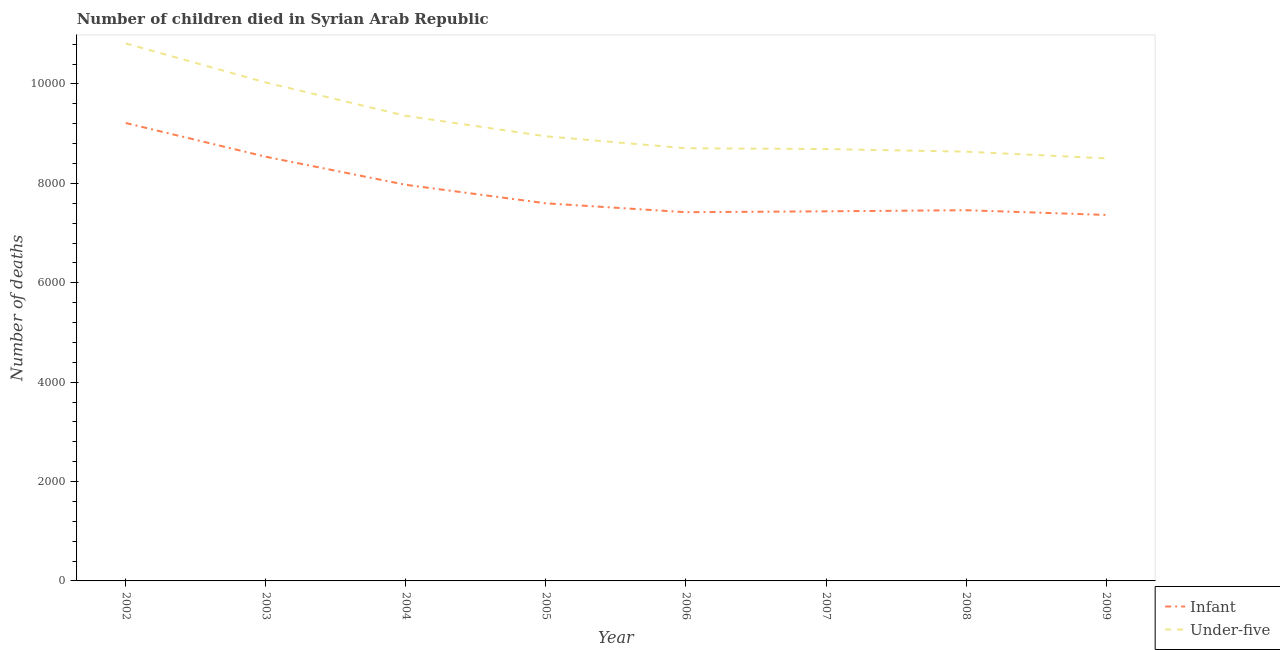What is the number of infant deaths in 2005?
Ensure brevity in your answer.  7599. Across all years, what is the maximum number of infant deaths?
Your answer should be very brief. 9215. Across all years, what is the minimum number of under-five deaths?
Your response must be concise. 8504. In which year was the number of under-five deaths maximum?
Offer a very short reply. 2002. What is the total number of under-five deaths in the graph?
Make the answer very short. 7.37e+04. What is the difference between the number of infant deaths in 2002 and that in 2006?
Ensure brevity in your answer.  1795. What is the difference between the number of infant deaths in 2004 and the number of under-five deaths in 2008?
Offer a very short reply. -667. What is the average number of under-five deaths per year?
Provide a short and direct response. 9211.5. In the year 2009, what is the difference between the number of under-five deaths and number of infant deaths?
Your answer should be very brief. 1139. What is the ratio of the number of under-five deaths in 2004 to that in 2009?
Provide a short and direct response. 1.1. What is the difference between the highest and the second highest number of infant deaths?
Provide a succinct answer. 679. What is the difference between the highest and the lowest number of under-five deaths?
Give a very brief answer. 2312. In how many years, is the number of infant deaths greater than the average number of infant deaths taken over all years?
Your answer should be very brief. 3. How many lines are there?
Your response must be concise. 2. What is the difference between two consecutive major ticks on the Y-axis?
Your answer should be compact. 2000. Are the values on the major ticks of Y-axis written in scientific E-notation?
Ensure brevity in your answer.  No. Where does the legend appear in the graph?
Offer a terse response. Bottom right. How many legend labels are there?
Make the answer very short. 2. What is the title of the graph?
Your answer should be compact. Number of children died in Syrian Arab Republic. Does "Malaria" appear as one of the legend labels in the graph?
Your response must be concise. No. What is the label or title of the Y-axis?
Give a very brief answer. Number of deaths. What is the Number of deaths in Infant in 2002?
Provide a short and direct response. 9215. What is the Number of deaths of Under-five in 2002?
Make the answer very short. 1.08e+04. What is the Number of deaths of Infant in 2003?
Provide a succinct answer. 8536. What is the Number of deaths of Under-five in 2003?
Provide a short and direct response. 1.00e+04. What is the Number of deaths of Infant in 2004?
Provide a succinct answer. 7971. What is the Number of deaths in Under-five in 2004?
Your response must be concise. 9359. What is the Number of deaths in Infant in 2005?
Provide a short and direct response. 7599. What is the Number of deaths of Under-five in 2005?
Offer a terse response. 8947. What is the Number of deaths in Infant in 2006?
Make the answer very short. 7420. What is the Number of deaths in Under-five in 2006?
Make the answer very short. 8707. What is the Number of deaths in Infant in 2007?
Your answer should be very brief. 7438. What is the Number of deaths in Under-five in 2007?
Your answer should be compact. 8691. What is the Number of deaths of Infant in 2008?
Offer a terse response. 7460. What is the Number of deaths in Under-five in 2008?
Your response must be concise. 8638. What is the Number of deaths in Infant in 2009?
Keep it short and to the point. 7365. What is the Number of deaths of Under-five in 2009?
Offer a very short reply. 8504. Across all years, what is the maximum Number of deaths in Infant?
Your answer should be compact. 9215. Across all years, what is the maximum Number of deaths of Under-five?
Ensure brevity in your answer.  1.08e+04. Across all years, what is the minimum Number of deaths in Infant?
Your answer should be very brief. 7365. Across all years, what is the minimum Number of deaths of Under-five?
Offer a very short reply. 8504. What is the total Number of deaths in Infant in the graph?
Give a very brief answer. 6.30e+04. What is the total Number of deaths in Under-five in the graph?
Provide a succinct answer. 7.37e+04. What is the difference between the Number of deaths of Infant in 2002 and that in 2003?
Your answer should be very brief. 679. What is the difference between the Number of deaths in Under-five in 2002 and that in 2003?
Your response must be concise. 786. What is the difference between the Number of deaths of Infant in 2002 and that in 2004?
Offer a very short reply. 1244. What is the difference between the Number of deaths in Under-five in 2002 and that in 2004?
Offer a terse response. 1457. What is the difference between the Number of deaths of Infant in 2002 and that in 2005?
Provide a succinct answer. 1616. What is the difference between the Number of deaths of Under-five in 2002 and that in 2005?
Give a very brief answer. 1869. What is the difference between the Number of deaths of Infant in 2002 and that in 2006?
Provide a short and direct response. 1795. What is the difference between the Number of deaths in Under-five in 2002 and that in 2006?
Offer a very short reply. 2109. What is the difference between the Number of deaths of Infant in 2002 and that in 2007?
Give a very brief answer. 1777. What is the difference between the Number of deaths of Under-five in 2002 and that in 2007?
Offer a very short reply. 2125. What is the difference between the Number of deaths of Infant in 2002 and that in 2008?
Your response must be concise. 1755. What is the difference between the Number of deaths of Under-five in 2002 and that in 2008?
Offer a terse response. 2178. What is the difference between the Number of deaths in Infant in 2002 and that in 2009?
Your answer should be compact. 1850. What is the difference between the Number of deaths in Under-five in 2002 and that in 2009?
Ensure brevity in your answer.  2312. What is the difference between the Number of deaths in Infant in 2003 and that in 2004?
Provide a short and direct response. 565. What is the difference between the Number of deaths in Under-five in 2003 and that in 2004?
Offer a terse response. 671. What is the difference between the Number of deaths of Infant in 2003 and that in 2005?
Your answer should be compact. 937. What is the difference between the Number of deaths of Under-five in 2003 and that in 2005?
Your answer should be very brief. 1083. What is the difference between the Number of deaths of Infant in 2003 and that in 2006?
Provide a short and direct response. 1116. What is the difference between the Number of deaths in Under-five in 2003 and that in 2006?
Keep it short and to the point. 1323. What is the difference between the Number of deaths in Infant in 2003 and that in 2007?
Give a very brief answer. 1098. What is the difference between the Number of deaths in Under-five in 2003 and that in 2007?
Provide a short and direct response. 1339. What is the difference between the Number of deaths in Infant in 2003 and that in 2008?
Your response must be concise. 1076. What is the difference between the Number of deaths in Under-five in 2003 and that in 2008?
Make the answer very short. 1392. What is the difference between the Number of deaths of Infant in 2003 and that in 2009?
Your answer should be compact. 1171. What is the difference between the Number of deaths of Under-five in 2003 and that in 2009?
Ensure brevity in your answer.  1526. What is the difference between the Number of deaths of Infant in 2004 and that in 2005?
Give a very brief answer. 372. What is the difference between the Number of deaths of Under-five in 2004 and that in 2005?
Your answer should be very brief. 412. What is the difference between the Number of deaths in Infant in 2004 and that in 2006?
Your answer should be very brief. 551. What is the difference between the Number of deaths of Under-five in 2004 and that in 2006?
Your response must be concise. 652. What is the difference between the Number of deaths of Infant in 2004 and that in 2007?
Ensure brevity in your answer.  533. What is the difference between the Number of deaths in Under-five in 2004 and that in 2007?
Provide a short and direct response. 668. What is the difference between the Number of deaths in Infant in 2004 and that in 2008?
Give a very brief answer. 511. What is the difference between the Number of deaths of Under-five in 2004 and that in 2008?
Give a very brief answer. 721. What is the difference between the Number of deaths of Infant in 2004 and that in 2009?
Provide a succinct answer. 606. What is the difference between the Number of deaths in Under-five in 2004 and that in 2009?
Provide a succinct answer. 855. What is the difference between the Number of deaths in Infant in 2005 and that in 2006?
Ensure brevity in your answer.  179. What is the difference between the Number of deaths of Under-five in 2005 and that in 2006?
Your answer should be compact. 240. What is the difference between the Number of deaths of Infant in 2005 and that in 2007?
Your answer should be compact. 161. What is the difference between the Number of deaths in Under-five in 2005 and that in 2007?
Your answer should be very brief. 256. What is the difference between the Number of deaths of Infant in 2005 and that in 2008?
Your answer should be compact. 139. What is the difference between the Number of deaths in Under-five in 2005 and that in 2008?
Keep it short and to the point. 309. What is the difference between the Number of deaths in Infant in 2005 and that in 2009?
Offer a terse response. 234. What is the difference between the Number of deaths in Under-five in 2005 and that in 2009?
Provide a succinct answer. 443. What is the difference between the Number of deaths in Infant in 2006 and that in 2007?
Keep it short and to the point. -18. What is the difference between the Number of deaths of Under-five in 2006 and that in 2009?
Provide a succinct answer. 203. What is the difference between the Number of deaths in Infant in 2007 and that in 2008?
Make the answer very short. -22. What is the difference between the Number of deaths in Under-five in 2007 and that in 2009?
Make the answer very short. 187. What is the difference between the Number of deaths of Infant in 2008 and that in 2009?
Ensure brevity in your answer.  95. What is the difference between the Number of deaths of Under-five in 2008 and that in 2009?
Provide a succinct answer. 134. What is the difference between the Number of deaths in Infant in 2002 and the Number of deaths in Under-five in 2003?
Make the answer very short. -815. What is the difference between the Number of deaths in Infant in 2002 and the Number of deaths in Under-five in 2004?
Ensure brevity in your answer.  -144. What is the difference between the Number of deaths of Infant in 2002 and the Number of deaths of Under-five in 2005?
Keep it short and to the point. 268. What is the difference between the Number of deaths in Infant in 2002 and the Number of deaths in Under-five in 2006?
Your response must be concise. 508. What is the difference between the Number of deaths of Infant in 2002 and the Number of deaths of Under-five in 2007?
Your response must be concise. 524. What is the difference between the Number of deaths in Infant in 2002 and the Number of deaths in Under-five in 2008?
Provide a short and direct response. 577. What is the difference between the Number of deaths of Infant in 2002 and the Number of deaths of Under-five in 2009?
Provide a short and direct response. 711. What is the difference between the Number of deaths in Infant in 2003 and the Number of deaths in Under-five in 2004?
Make the answer very short. -823. What is the difference between the Number of deaths in Infant in 2003 and the Number of deaths in Under-five in 2005?
Offer a very short reply. -411. What is the difference between the Number of deaths of Infant in 2003 and the Number of deaths of Under-five in 2006?
Your response must be concise. -171. What is the difference between the Number of deaths in Infant in 2003 and the Number of deaths in Under-five in 2007?
Keep it short and to the point. -155. What is the difference between the Number of deaths in Infant in 2003 and the Number of deaths in Under-five in 2008?
Offer a terse response. -102. What is the difference between the Number of deaths in Infant in 2003 and the Number of deaths in Under-five in 2009?
Ensure brevity in your answer.  32. What is the difference between the Number of deaths of Infant in 2004 and the Number of deaths of Under-five in 2005?
Offer a terse response. -976. What is the difference between the Number of deaths in Infant in 2004 and the Number of deaths in Under-five in 2006?
Make the answer very short. -736. What is the difference between the Number of deaths in Infant in 2004 and the Number of deaths in Under-five in 2007?
Provide a succinct answer. -720. What is the difference between the Number of deaths in Infant in 2004 and the Number of deaths in Under-five in 2008?
Make the answer very short. -667. What is the difference between the Number of deaths in Infant in 2004 and the Number of deaths in Under-five in 2009?
Your response must be concise. -533. What is the difference between the Number of deaths of Infant in 2005 and the Number of deaths of Under-five in 2006?
Your answer should be compact. -1108. What is the difference between the Number of deaths in Infant in 2005 and the Number of deaths in Under-five in 2007?
Your answer should be very brief. -1092. What is the difference between the Number of deaths in Infant in 2005 and the Number of deaths in Under-five in 2008?
Your answer should be very brief. -1039. What is the difference between the Number of deaths in Infant in 2005 and the Number of deaths in Under-five in 2009?
Your response must be concise. -905. What is the difference between the Number of deaths of Infant in 2006 and the Number of deaths of Under-five in 2007?
Give a very brief answer. -1271. What is the difference between the Number of deaths of Infant in 2006 and the Number of deaths of Under-five in 2008?
Give a very brief answer. -1218. What is the difference between the Number of deaths of Infant in 2006 and the Number of deaths of Under-five in 2009?
Your answer should be compact. -1084. What is the difference between the Number of deaths of Infant in 2007 and the Number of deaths of Under-five in 2008?
Your response must be concise. -1200. What is the difference between the Number of deaths in Infant in 2007 and the Number of deaths in Under-five in 2009?
Offer a very short reply. -1066. What is the difference between the Number of deaths of Infant in 2008 and the Number of deaths of Under-five in 2009?
Make the answer very short. -1044. What is the average Number of deaths of Infant per year?
Give a very brief answer. 7875.5. What is the average Number of deaths in Under-five per year?
Your answer should be very brief. 9211.5. In the year 2002, what is the difference between the Number of deaths of Infant and Number of deaths of Under-five?
Ensure brevity in your answer.  -1601. In the year 2003, what is the difference between the Number of deaths of Infant and Number of deaths of Under-five?
Keep it short and to the point. -1494. In the year 2004, what is the difference between the Number of deaths in Infant and Number of deaths in Under-five?
Ensure brevity in your answer.  -1388. In the year 2005, what is the difference between the Number of deaths in Infant and Number of deaths in Under-five?
Provide a succinct answer. -1348. In the year 2006, what is the difference between the Number of deaths of Infant and Number of deaths of Under-five?
Provide a short and direct response. -1287. In the year 2007, what is the difference between the Number of deaths of Infant and Number of deaths of Under-five?
Give a very brief answer. -1253. In the year 2008, what is the difference between the Number of deaths in Infant and Number of deaths in Under-five?
Offer a terse response. -1178. In the year 2009, what is the difference between the Number of deaths of Infant and Number of deaths of Under-five?
Give a very brief answer. -1139. What is the ratio of the Number of deaths in Infant in 2002 to that in 2003?
Your answer should be compact. 1.08. What is the ratio of the Number of deaths of Under-five in 2002 to that in 2003?
Your answer should be compact. 1.08. What is the ratio of the Number of deaths in Infant in 2002 to that in 2004?
Provide a succinct answer. 1.16. What is the ratio of the Number of deaths in Under-five in 2002 to that in 2004?
Provide a short and direct response. 1.16. What is the ratio of the Number of deaths in Infant in 2002 to that in 2005?
Offer a terse response. 1.21. What is the ratio of the Number of deaths of Under-five in 2002 to that in 2005?
Your answer should be very brief. 1.21. What is the ratio of the Number of deaths of Infant in 2002 to that in 2006?
Your answer should be very brief. 1.24. What is the ratio of the Number of deaths of Under-five in 2002 to that in 2006?
Your response must be concise. 1.24. What is the ratio of the Number of deaths of Infant in 2002 to that in 2007?
Your response must be concise. 1.24. What is the ratio of the Number of deaths in Under-five in 2002 to that in 2007?
Your response must be concise. 1.24. What is the ratio of the Number of deaths in Infant in 2002 to that in 2008?
Provide a short and direct response. 1.24. What is the ratio of the Number of deaths of Under-five in 2002 to that in 2008?
Your answer should be compact. 1.25. What is the ratio of the Number of deaths of Infant in 2002 to that in 2009?
Provide a succinct answer. 1.25. What is the ratio of the Number of deaths of Under-five in 2002 to that in 2009?
Keep it short and to the point. 1.27. What is the ratio of the Number of deaths in Infant in 2003 to that in 2004?
Ensure brevity in your answer.  1.07. What is the ratio of the Number of deaths in Under-five in 2003 to that in 2004?
Offer a terse response. 1.07. What is the ratio of the Number of deaths of Infant in 2003 to that in 2005?
Give a very brief answer. 1.12. What is the ratio of the Number of deaths in Under-five in 2003 to that in 2005?
Your answer should be compact. 1.12. What is the ratio of the Number of deaths of Infant in 2003 to that in 2006?
Give a very brief answer. 1.15. What is the ratio of the Number of deaths of Under-five in 2003 to that in 2006?
Offer a terse response. 1.15. What is the ratio of the Number of deaths in Infant in 2003 to that in 2007?
Provide a succinct answer. 1.15. What is the ratio of the Number of deaths in Under-five in 2003 to that in 2007?
Your answer should be very brief. 1.15. What is the ratio of the Number of deaths of Infant in 2003 to that in 2008?
Your response must be concise. 1.14. What is the ratio of the Number of deaths of Under-five in 2003 to that in 2008?
Your answer should be compact. 1.16. What is the ratio of the Number of deaths in Infant in 2003 to that in 2009?
Provide a short and direct response. 1.16. What is the ratio of the Number of deaths of Under-five in 2003 to that in 2009?
Your answer should be very brief. 1.18. What is the ratio of the Number of deaths of Infant in 2004 to that in 2005?
Offer a very short reply. 1.05. What is the ratio of the Number of deaths in Under-five in 2004 to that in 2005?
Ensure brevity in your answer.  1.05. What is the ratio of the Number of deaths in Infant in 2004 to that in 2006?
Keep it short and to the point. 1.07. What is the ratio of the Number of deaths of Under-five in 2004 to that in 2006?
Your answer should be very brief. 1.07. What is the ratio of the Number of deaths in Infant in 2004 to that in 2007?
Keep it short and to the point. 1.07. What is the ratio of the Number of deaths of Under-five in 2004 to that in 2007?
Keep it short and to the point. 1.08. What is the ratio of the Number of deaths of Infant in 2004 to that in 2008?
Provide a short and direct response. 1.07. What is the ratio of the Number of deaths in Under-five in 2004 to that in 2008?
Provide a succinct answer. 1.08. What is the ratio of the Number of deaths in Infant in 2004 to that in 2009?
Provide a short and direct response. 1.08. What is the ratio of the Number of deaths in Under-five in 2004 to that in 2009?
Your answer should be very brief. 1.1. What is the ratio of the Number of deaths in Infant in 2005 to that in 2006?
Your response must be concise. 1.02. What is the ratio of the Number of deaths in Under-five in 2005 to that in 2006?
Your answer should be compact. 1.03. What is the ratio of the Number of deaths of Infant in 2005 to that in 2007?
Offer a very short reply. 1.02. What is the ratio of the Number of deaths of Under-five in 2005 to that in 2007?
Your response must be concise. 1.03. What is the ratio of the Number of deaths in Infant in 2005 to that in 2008?
Ensure brevity in your answer.  1.02. What is the ratio of the Number of deaths in Under-five in 2005 to that in 2008?
Your answer should be compact. 1.04. What is the ratio of the Number of deaths of Infant in 2005 to that in 2009?
Your response must be concise. 1.03. What is the ratio of the Number of deaths in Under-five in 2005 to that in 2009?
Keep it short and to the point. 1.05. What is the ratio of the Number of deaths of Infant in 2006 to that in 2008?
Offer a terse response. 0.99. What is the ratio of the Number of deaths of Infant in 2006 to that in 2009?
Your response must be concise. 1.01. What is the ratio of the Number of deaths of Under-five in 2006 to that in 2009?
Offer a terse response. 1.02. What is the ratio of the Number of deaths of Under-five in 2007 to that in 2008?
Offer a terse response. 1.01. What is the ratio of the Number of deaths in Infant in 2007 to that in 2009?
Your response must be concise. 1.01. What is the ratio of the Number of deaths in Infant in 2008 to that in 2009?
Ensure brevity in your answer.  1.01. What is the ratio of the Number of deaths in Under-five in 2008 to that in 2009?
Your answer should be very brief. 1.02. What is the difference between the highest and the second highest Number of deaths of Infant?
Your response must be concise. 679. What is the difference between the highest and the second highest Number of deaths in Under-five?
Your answer should be very brief. 786. What is the difference between the highest and the lowest Number of deaths of Infant?
Keep it short and to the point. 1850. What is the difference between the highest and the lowest Number of deaths in Under-five?
Offer a very short reply. 2312. 